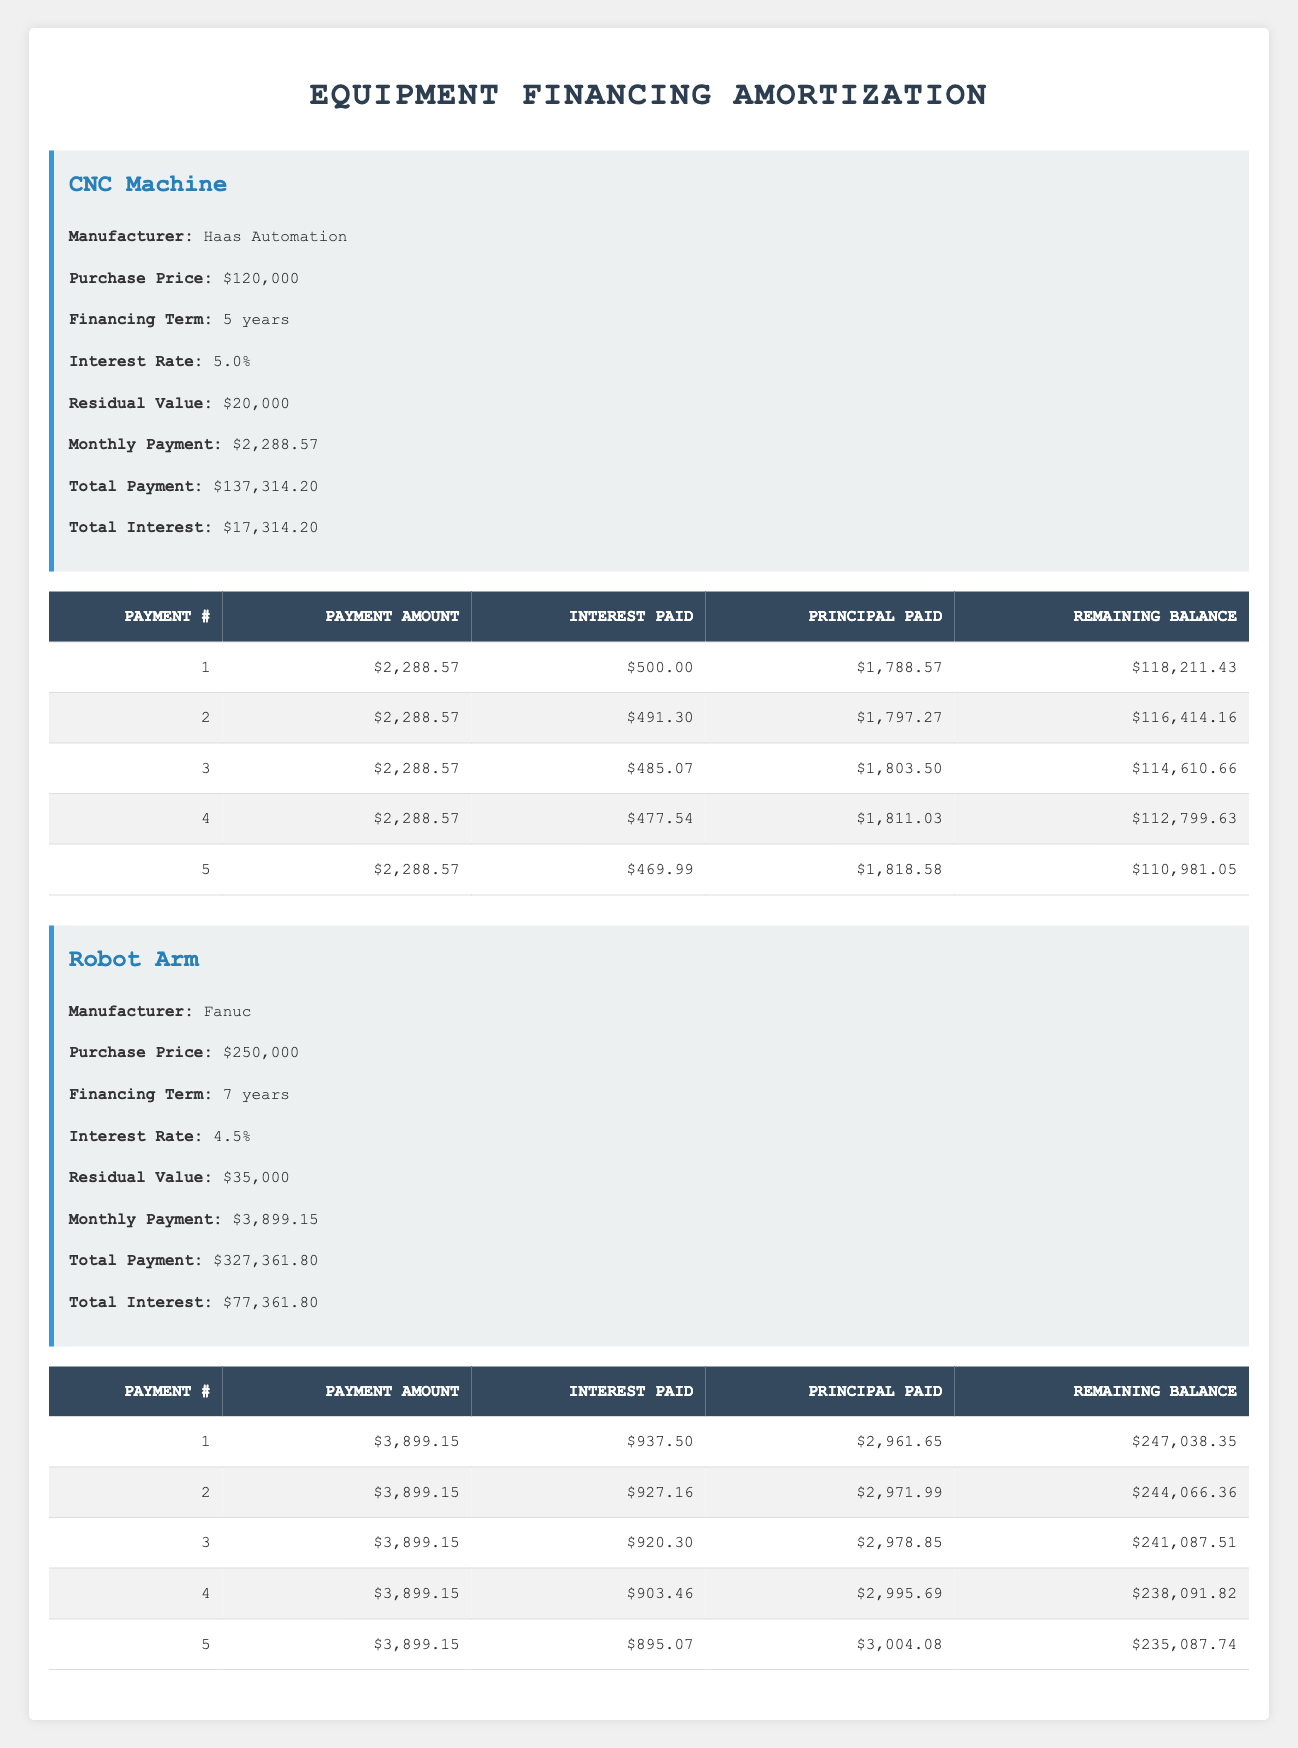What is the purchase price of the CNC Machine? The purchase price of the CNC Machine is listed in the equipment information section as $120,000.
Answer: $120,000 What is the total interest paid for the Robot Arm over the financing term? The total interest for the Robot Arm is provided in the equipment information section and is stated as $77,361.80.
Answer: $77,361.80 How much is the principal paid in the first payment for the CNC Machine? The principal paid for the first payment of the CNC Machine can be found in the amortization details under the "Principal Paid" column for Payment #1, which is $1,788.57.
Answer: $1,788.57 What is the remaining balance after the 5th payment for the Robot Arm? The remaining balance after the 5th payment can be found in the amortization details under the "Remaining Balance" column for Payment #5, which shows $235,087.74.
Answer: $235,087.74 What is the average monthly payment for the CNC Machine? The monthly payment for the CNC Machine is $2,288.57. Since there are 5 payments, the average remains the same as there are no variations.
Answer: $2,288.57 Is the interest rate for the Robot Arm higher than that of the CNC Machine? The interest rate for the Robot Arm is 4.5%, while for the CNC Machine it is 5.0%. Therefore, the statement is false.
Answer: No How much total principal was paid in the first 5 payments of the CNC Machine? To find the total principal paid, sum the "Principal Paid" values from payments 1 to 5: $1,788.57 + $1,797.27 + $1,803.50 + $1,811.03 + $1,818.58 = $9,218.95.
Answer: $9,218.95 What is the difference in total payments between the CNC Machine and the Robot Arm? The total payment for the CNC Machine is $137,314.20, and for the Robot Arm, it is $327,361.80. The difference is calculated as $327,361.80 - $137,314.20 = $190,047.60.
Answer: $190,047.60 Did the interest paid decrease with each successive payment for the CNC Machine? Observing the interest paid for each of the first 5 payments shows a declining pattern: $500.00, $491.30, $485.07, $477.54, and $469.99, confirming a decrease in interest paid.
Answer: Yes 